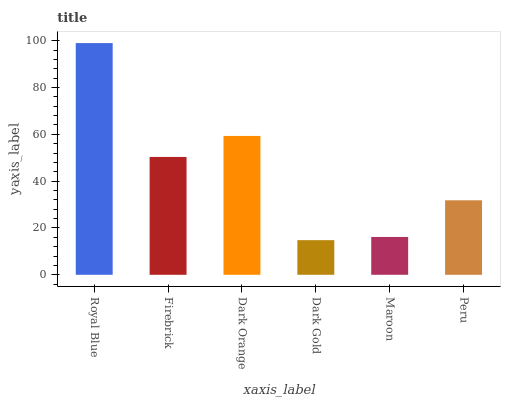Is Dark Gold the minimum?
Answer yes or no. Yes. Is Royal Blue the maximum?
Answer yes or no. Yes. Is Firebrick the minimum?
Answer yes or no. No. Is Firebrick the maximum?
Answer yes or no. No. Is Royal Blue greater than Firebrick?
Answer yes or no. Yes. Is Firebrick less than Royal Blue?
Answer yes or no. Yes. Is Firebrick greater than Royal Blue?
Answer yes or no. No. Is Royal Blue less than Firebrick?
Answer yes or no. No. Is Firebrick the high median?
Answer yes or no. Yes. Is Peru the low median?
Answer yes or no. Yes. Is Maroon the high median?
Answer yes or no. No. Is Maroon the low median?
Answer yes or no. No. 